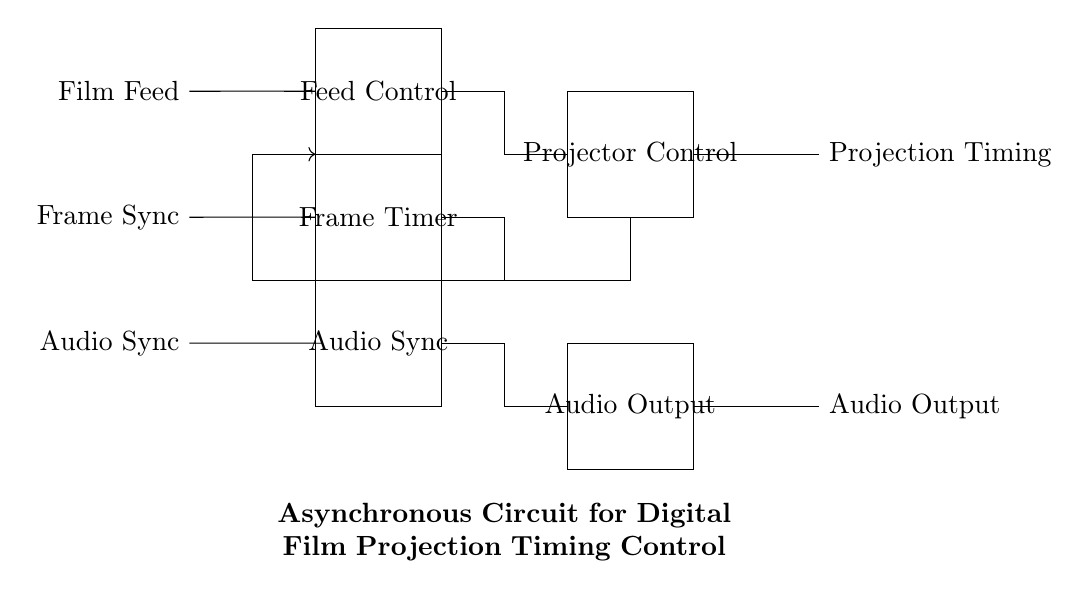What signals are input to the circuit? The input signals to the circuit are Film Feed, Frame Sync, and Audio Sync, as indicated by the labels on the left side of the diagram.
Answer: Film Feed, Frame Sync, Audio Sync What does the Feed Control block do? The Feed Control block regulates or manages the film feed mechanism, ensuring that the film is fed correctly to the projector at the right time.
Answer: Film feed regulation How many logic blocks are present in the circuit? There are a total of three logic blocks, which are Feed Control, Frame Timer, and Audio Sync. They are arranged in a vertical stack in the circuit.
Answer: Three What is the function of the Projector Control block? The Projector Control block coordinates the operation of the projector, managing the timing of the film projection based on the inputs received from the asynchronous logic blocks.
Answer: Projector operation coordination What feedback mechanism is indicated in the circuit? The feedback mechanism is shown by the arrow that loops from the Projector Control back to the Frame Timer and Feed Control, indicating that output from the projector influences the timing control inputs.
Answer: Feedback loop How is audio handled in the circuit? Audio is managed through the Audio Sync logic block, which synchronizes audio output with the film projection, ensuring both elements play in harmony.
Answer: Audio synchronization 